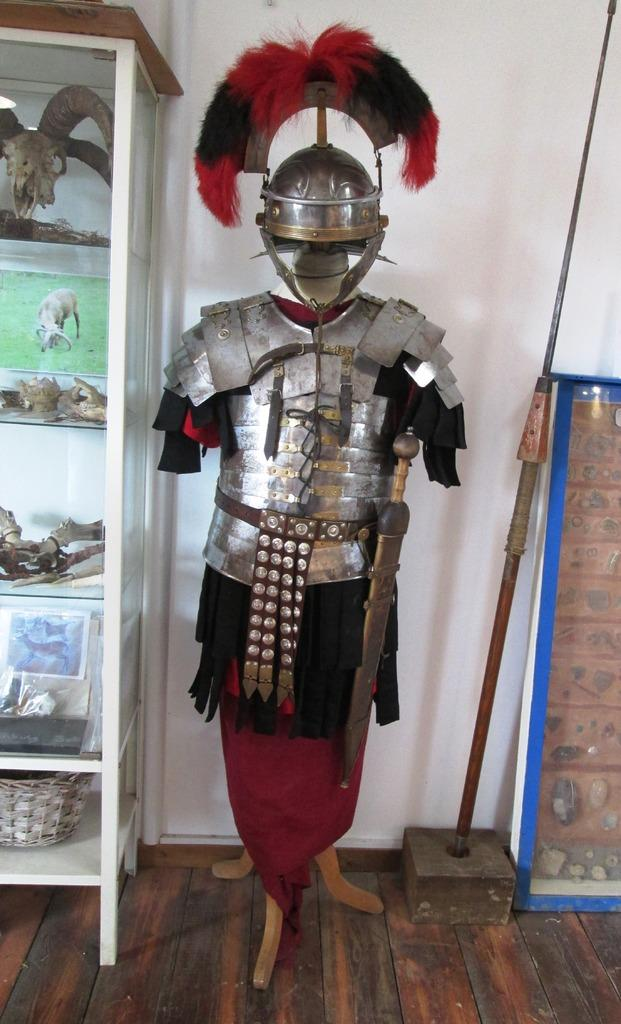What type of costume is visible in the image? There is a metal costume in the image. What can be seen on the left side of the image? There is a rack on the left side of the image. What is in the background of the image? There is a wall in the background of the image. What type of flooring is present in the image? There is a wooden floor in the image. How does the costume help improve the memory of the person wearing it? The image does not provide any information about the costume's effect on memory, as it only shows the costume itself and not its function or purpose. 